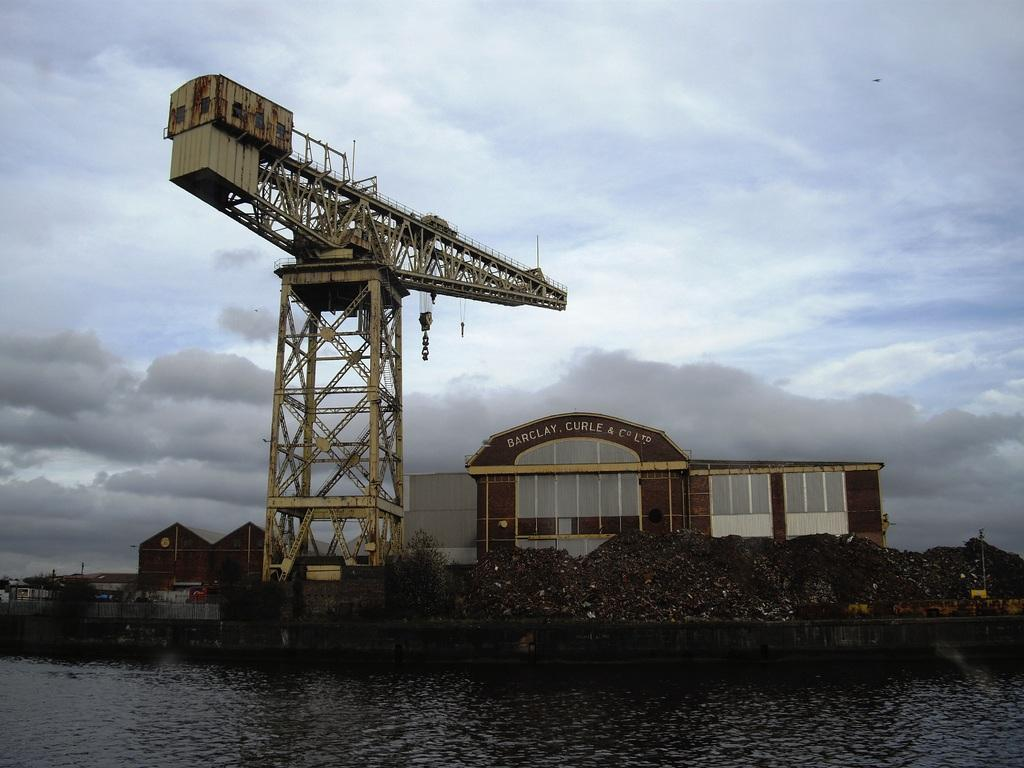What is the main subject of the image? There is a crane in the image. What else can be seen in the image besides the crane? There are buildings and a lake at the bottom of the image. The sky is also visible at the top of the image. What is the condition of the sky in the image? Clouds are present in the sky. How many pages are visible in the image? There are no pages present in the image. Are there any giants visible in the image? There are no giants present in the image. 